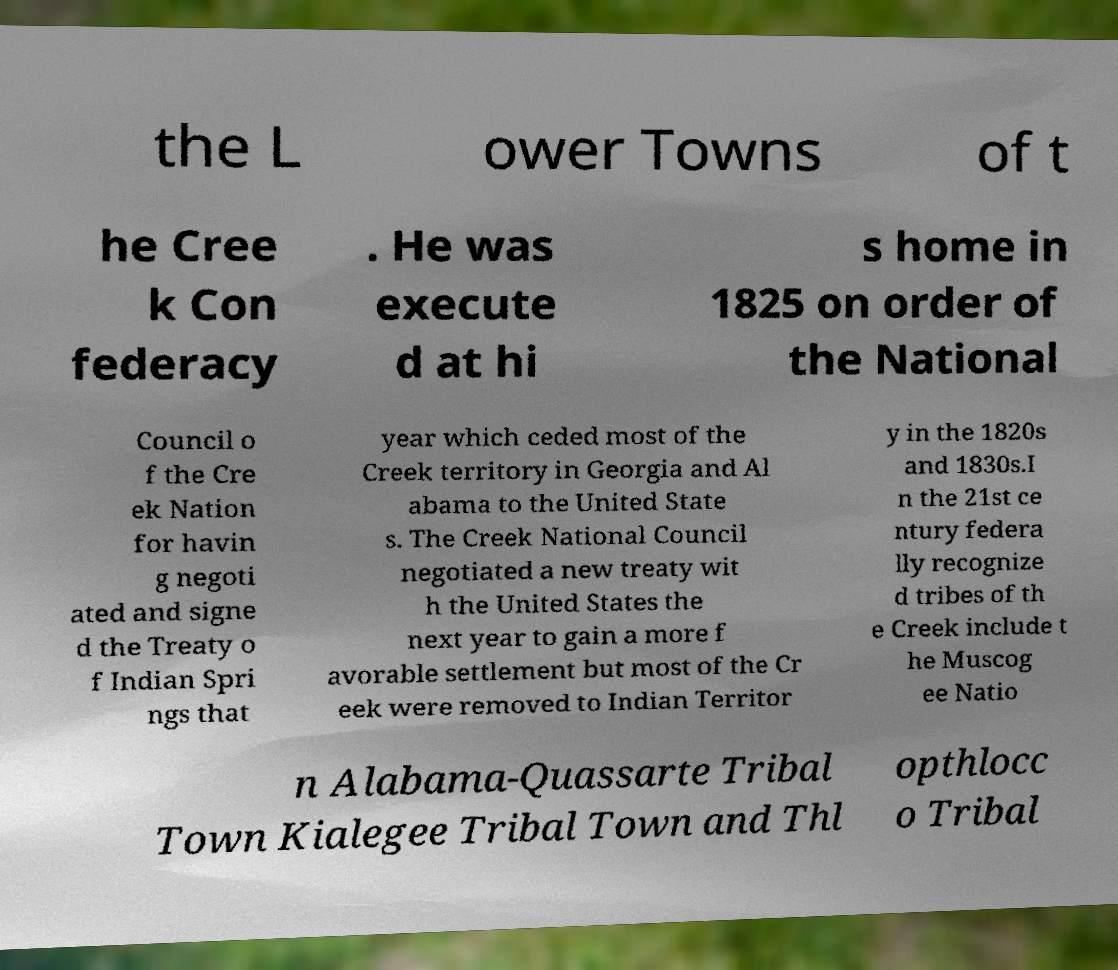Please identify and transcribe the text found in this image. the L ower Towns of t he Cree k Con federacy . He was execute d at hi s home in 1825 on order of the National Council o f the Cre ek Nation for havin g negoti ated and signe d the Treaty o f Indian Spri ngs that year which ceded most of the Creek territory in Georgia and Al abama to the United State s. The Creek National Council negotiated a new treaty wit h the United States the next year to gain a more f avorable settlement but most of the Cr eek were removed to Indian Territor y in the 1820s and 1830s.I n the 21st ce ntury federa lly recognize d tribes of th e Creek include t he Muscog ee Natio n Alabama-Quassarte Tribal Town Kialegee Tribal Town and Thl opthlocc o Tribal 